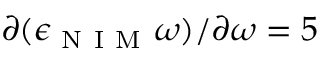<formula> <loc_0><loc_0><loc_500><loc_500>\partial ( \epsilon _ { N I M } \omega ) / \partial \omega = 5</formula> 